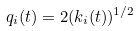<formula> <loc_0><loc_0><loc_500><loc_500>q _ { i } ( t ) = 2 ( k _ { i } ( t ) ) ^ { 1 / 2 }</formula> 